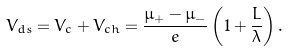<formula> <loc_0><loc_0><loc_500><loc_500>V _ { d s } = V _ { c } + V _ { c h } = \frac { \mu _ { + } - \mu _ { - } } { e } \left ( 1 + \frac { L } { \lambda } \right ) .</formula> 